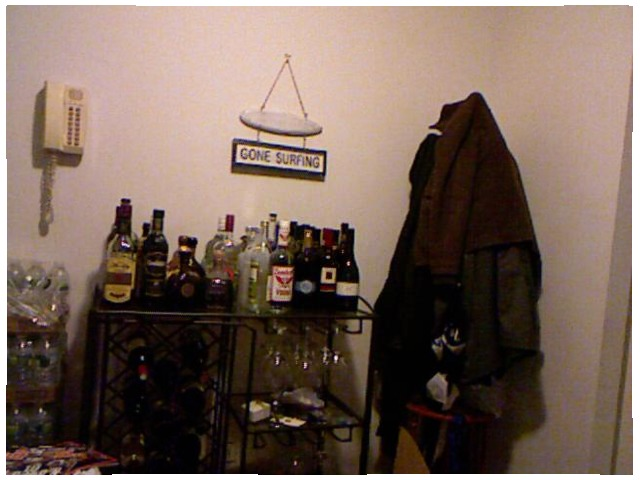<image>
Is there a sign above the alcohol? Yes. The sign is positioned above the alcohol in the vertical space, higher up in the scene. 